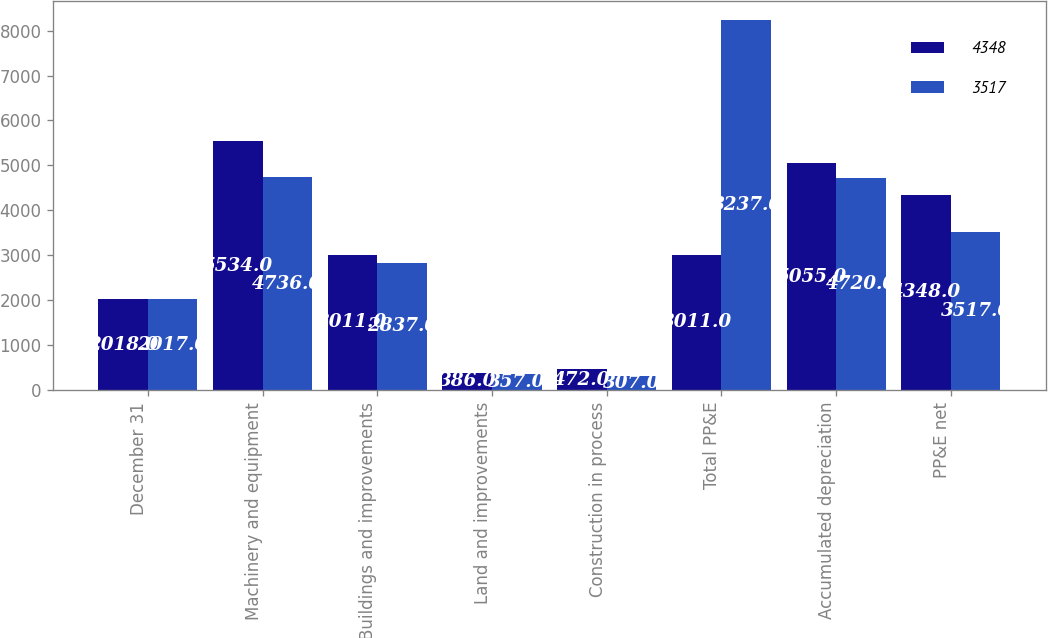Convert chart to OTSL. <chart><loc_0><loc_0><loc_500><loc_500><stacked_bar_chart><ecel><fcel>December 31<fcel>Machinery and equipment<fcel>Buildings and improvements<fcel>Land and improvements<fcel>Construction in process<fcel>Total PP&E<fcel>Accumulated depreciation<fcel>PP&E net<nl><fcel>4348<fcel>2018<fcel>5534<fcel>3011<fcel>386<fcel>472<fcel>3011<fcel>5055<fcel>4348<nl><fcel>3517<fcel>2017<fcel>4736<fcel>2837<fcel>357<fcel>307<fcel>8237<fcel>4720<fcel>3517<nl></chart> 